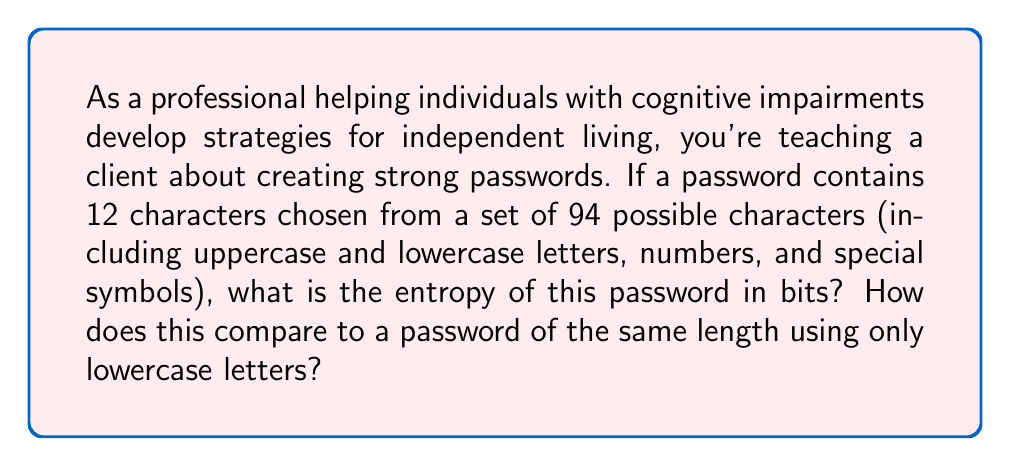Help me with this question. Let's approach this step-by-step:

1) The formula for password entropy is:
   
   $$ E = log_2(R^L) $$
   
   Where $E$ is entropy, $R$ is the size of the character set, and $L$ is the length of the password.

2) For the first password:
   $R = 94$ (all possible characters)
   $L = 12$ (length of the password)

   $$ E = log_2(94^{12}) $$

3) Using the properties of logarithms:
   
   $$ E = 12 * log_2(94) $$

4) Calculating this:
   
   $$ E ≈ 12 * 6.55 = 78.6 \text{ bits} $$

5) For the password using only lowercase letters:
   $R = 26$ (26 lowercase letters)
   $L = 12$ (length remains the same)

   $$ E = 12 * log_2(26) ≈ 12 * 4.7 = 56.4 \text{ bits} $$

6) Comparing the two:
   The password using all possible characters has about 22.2 bits more entropy than the one using only lowercase letters. This means it's $2^{22.2} ≈ 4,718,592$ times stronger.

This demonstrates how using a diverse set of characters significantly increases password strength, which is crucial for protecting sensitive information.
Answer: 78.6 bits; 22.2 bits stronger than lowercase-only 